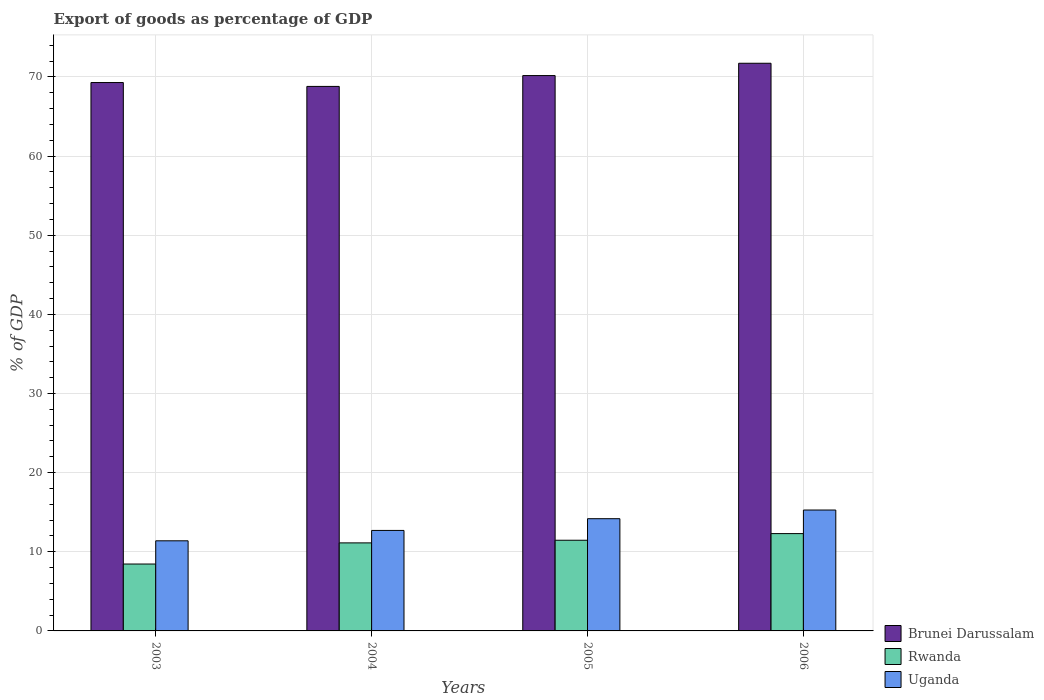How many different coloured bars are there?
Your answer should be compact. 3. How many groups of bars are there?
Offer a very short reply. 4. Are the number of bars per tick equal to the number of legend labels?
Make the answer very short. Yes. Are the number of bars on each tick of the X-axis equal?
Give a very brief answer. Yes. What is the export of goods as percentage of GDP in Uganda in 2004?
Your answer should be very brief. 12.7. Across all years, what is the maximum export of goods as percentage of GDP in Uganda?
Your answer should be compact. 15.28. Across all years, what is the minimum export of goods as percentage of GDP in Rwanda?
Provide a short and direct response. 8.45. In which year was the export of goods as percentage of GDP in Rwanda maximum?
Offer a terse response. 2006. What is the total export of goods as percentage of GDP in Uganda in the graph?
Provide a succinct answer. 53.54. What is the difference between the export of goods as percentage of GDP in Brunei Darussalam in 2003 and that in 2006?
Keep it short and to the point. -2.44. What is the difference between the export of goods as percentage of GDP in Rwanda in 2005 and the export of goods as percentage of GDP in Brunei Darussalam in 2004?
Offer a terse response. -57.34. What is the average export of goods as percentage of GDP in Brunei Darussalam per year?
Your response must be concise. 70. In the year 2004, what is the difference between the export of goods as percentage of GDP in Rwanda and export of goods as percentage of GDP in Brunei Darussalam?
Your answer should be very brief. -57.68. What is the ratio of the export of goods as percentage of GDP in Rwanda in 2005 to that in 2006?
Make the answer very short. 0.93. What is the difference between the highest and the second highest export of goods as percentage of GDP in Brunei Darussalam?
Give a very brief answer. 1.56. What is the difference between the highest and the lowest export of goods as percentage of GDP in Brunei Darussalam?
Your answer should be very brief. 2.93. Is the sum of the export of goods as percentage of GDP in Uganda in 2004 and 2005 greater than the maximum export of goods as percentage of GDP in Brunei Darussalam across all years?
Offer a terse response. No. What does the 2nd bar from the left in 2004 represents?
Your answer should be very brief. Rwanda. What does the 2nd bar from the right in 2005 represents?
Your answer should be very brief. Rwanda. Is it the case that in every year, the sum of the export of goods as percentage of GDP in Brunei Darussalam and export of goods as percentage of GDP in Rwanda is greater than the export of goods as percentage of GDP in Uganda?
Provide a short and direct response. Yes. Are all the bars in the graph horizontal?
Ensure brevity in your answer.  No. What is the difference between two consecutive major ticks on the Y-axis?
Offer a very short reply. 10. Are the values on the major ticks of Y-axis written in scientific E-notation?
Your response must be concise. No. Does the graph contain any zero values?
Your response must be concise. No. How many legend labels are there?
Your answer should be very brief. 3. How are the legend labels stacked?
Your response must be concise. Vertical. What is the title of the graph?
Your response must be concise. Export of goods as percentage of GDP. What is the label or title of the Y-axis?
Make the answer very short. % of GDP. What is the % of GDP in Brunei Darussalam in 2003?
Offer a very short reply. 69.29. What is the % of GDP of Rwanda in 2003?
Keep it short and to the point. 8.45. What is the % of GDP of Uganda in 2003?
Offer a very short reply. 11.39. What is the % of GDP of Brunei Darussalam in 2004?
Provide a short and direct response. 68.8. What is the % of GDP in Rwanda in 2004?
Ensure brevity in your answer.  11.12. What is the % of GDP in Uganda in 2004?
Offer a terse response. 12.7. What is the % of GDP of Brunei Darussalam in 2005?
Your answer should be very brief. 70.17. What is the % of GDP of Rwanda in 2005?
Provide a succinct answer. 11.46. What is the % of GDP of Uganda in 2005?
Your response must be concise. 14.18. What is the % of GDP in Brunei Darussalam in 2006?
Offer a very short reply. 71.72. What is the % of GDP in Rwanda in 2006?
Offer a terse response. 12.3. What is the % of GDP of Uganda in 2006?
Provide a short and direct response. 15.28. Across all years, what is the maximum % of GDP of Brunei Darussalam?
Keep it short and to the point. 71.72. Across all years, what is the maximum % of GDP in Rwanda?
Your answer should be compact. 12.3. Across all years, what is the maximum % of GDP of Uganda?
Make the answer very short. 15.28. Across all years, what is the minimum % of GDP in Brunei Darussalam?
Your answer should be compact. 68.8. Across all years, what is the minimum % of GDP in Rwanda?
Give a very brief answer. 8.45. Across all years, what is the minimum % of GDP in Uganda?
Your response must be concise. 11.39. What is the total % of GDP of Brunei Darussalam in the graph?
Your answer should be compact. 279.98. What is the total % of GDP in Rwanda in the graph?
Ensure brevity in your answer.  43.33. What is the total % of GDP of Uganda in the graph?
Offer a very short reply. 53.54. What is the difference between the % of GDP in Brunei Darussalam in 2003 and that in 2004?
Your response must be concise. 0.49. What is the difference between the % of GDP in Rwanda in 2003 and that in 2004?
Offer a terse response. -2.67. What is the difference between the % of GDP of Uganda in 2003 and that in 2004?
Ensure brevity in your answer.  -1.31. What is the difference between the % of GDP of Brunei Darussalam in 2003 and that in 2005?
Ensure brevity in your answer.  -0.88. What is the difference between the % of GDP in Rwanda in 2003 and that in 2005?
Your answer should be very brief. -3. What is the difference between the % of GDP of Uganda in 2003 and that in 2005?
Ensure brevity in your answer.  -2.79. What is the difference between the % of GDP in Brunei Darussalam in 2003 and that in 2006?
Provide a succinct answer. -2.44. What is the difference between the % of GDP of Rwanda in 2003 and that in 2006?
Your response must be concise. -3.84. What is the difference between the % of GDP in Uganda in 2003 and that in 2006?
Make the answer very short. -3.89. What is the difference between the % of GDP in Brunei Darussalam in 2004 and that in 2005?
Offer a very short reply. -1.37. What is the difference between the % of GDP of Rwanda in 2004 and that in 2005?
Your answer should be very brief. -0.33. What is the difference between the % of GDP in Uganda in 2004 and that in 2005?
Ensure brevity in your answer.  -1.48. What is the difference between the % of GDP of Brunei Darussalam in 2004 and that in 2006?
Provide a short and direct response. -2.93. What is the difference between the % of GDP in Rwanda in 2004 and that in 2006?
Your response must be concise. -1.17. What is the difference between the % of GDP in Uganda in 2004 and that in 2006?
Offer a very short reply. -2.58. What is the difference between the % of GDP in Brunei Darussalam in 2005 and that in 2006?
Give a very brief answer. -1.56. What is the difference between the % of GDP in Rwanda in 2005 and that in 2006?
Ensure brevity in your answer.  -0.84. What is the difference between the % of GDP in Uganda in 2005 and that in 2006?
Ensure brevity in your answer.  -1.1. What is the difference between the % of GDP in Brunei Darussalam in 2003 and the % of GDP in Rwanda in 2004?
Give a very brief answer. 58.17. What is the difference between the % of GDP in Brunei Darussalam in 2003 and the % of GDP in Uganda in 2004?
Keep it short and to the point. 56.59. What is the difference between the % of GDP in Rwanda in 2003 and the % of GDP in Uganda in 2004?
Give a very brief answer. -4.24. What is the difference between the % of GDP in Brunei Darussalam in 2003 and the % of GDP in Rwanda in 2005?
Provide a succinct answer. 57.83. What is the difference between the % of GDP of Brunei Darussalam in 2003 and the % of GDP of Uganda in 2005?
Keep it short and to the point. 55.11. What is the difference between the % of GDP in Rwanda in 2003 and the % of GDP in Uganda in 2005?
Your answer should be compact. -5.73. What is the difference between the % of GDP of Brunei Darussalam in 2003 and the % of GDP of Rwanda in 2006?
Keep it short and to the point. 56.99. What is the difference between the % of GDP in Brunei Darussalam in 2003 and the % of GDP in Uganda in 2006?
Make the answer very short. 54.01. What is the difference between the % of GDP of Rwanda in 2003 and the % of GDP of Uganda in 2006?
Your answer should be compact. -6.82. What is the difference between the % of GDP of Brunei Darussalam in 2004 and the % of GDP of Rwanda in 2005?
Provide a short and direct response. 57.34. What is the difference between the % of GDP of Brunei Darussalam in 2004 and the % of GDP of Uganda in 2005?
Make the answer very short. 54.62. What is the difference between the % of GDP of Rwanda in 2004 and the % of GDP of Uganda in 2005?
Your response must be concise. -3.06. What is the difference between the % of GDP of Brunei Darussalam in 2004 and the % of GDP of Rwanda in 2006?
Ensure brevity in your answer.  56.5. What is the difference between the % of GDP of Brunei Darussalam in 2004 and the % of GDP of Uganda in 2006?
Ensure brevity in your answer.  53.52. What is the difference between the % of GDP in Rwanda in 2004 and the % of GDP in Uganda in 2006?
Make the answer very short. -4.15. What is the difference between the % of GDP of Brunei Darussalam in 2005 and the % of GDP of Rwanda in 2006?
Provide a short and direct response. 57.87. What is the difference between the % of GDP in Brunei Darussalam in 2005 and the % of GDP in Uganda in 2006?
Your answer should be compact. 54.89. What is the difference between the % of GDP in Rwanda in 2005 and the % of GDP in Uganda in 2006?
Your answer should be compact. -3.82. What is the average % of GDP in Brunei Darussalam per year?
Your answer should be compact. 70. What is the average % of GDP of Rwanda per year?
Keep it short and to the point. 10.83. What is the average % of GDP in Uganda per year?
Ensure brevity in your answer.  13.38. In the year 2003, what is the difference between the % of GDP in Brunei Darussalam and % of GDP in Rwanda?
Your response must be concise. 60.84. In the year 2003, what is the difference between the % of GDP of Brunei Darussalam and % of GDP of Uganda?
Your answer should be compact. 57.9. In the year 2003, what is the difference between the % of GDP of Rwanda and % of GDP of Uganda?
Offer a very short reply. -2.93. In the year 2004, what is the difference between the % of GDP in Brunei Darussalam and % of GDP in Rwanda?
Keep it short and to the point. 57.67. In the year 2004, what is the difference between the % of GDP of Brunei Darussalam and % of GDP of Uganda?
Ensure brevity in your answer.  56.1. In the year 2004, what is the difference between the % of GDP of Rwanda and % of GDP of Uganda?
Keep it short and to the point. -1.57. In the year 2005, what is the difference between the % of GDP of Brunei Darussalam and % of GDP of Rwanda?
Provide a short and direct response. 58.71. In the year 2005, what is the difference between the % of GDP of Brunei Darussalam and % of GDP of Uganda?
Provide a short and direct response. 55.99. In the year 2005, what is the difference between the % of GDP of Rwanda and % of GDP of Uganda?
Your answer should be very brief. -2.72. In the year 2006, what is the difference between the % of GDP in Brunei Darussalam and % of GDP in Rwanda?
Keep it short and to the point. 59.43. In the year 2006, what is the difference between the % of GDP in Brunei Darussalam and % of GDP in Uganda?
Provide a succinct answer. 56.45. In the year 2006, what is the difference between the % of GDP of Rwanda and % of GDP of Uganda?
Keep it short and to the point. -2.98. What is the ratio of the % of GDP in Brunei Darussalam in 2003 to that in 2004?
Your answer should be very brief. 1.01. What is the ratio of the % of GDP in Rwanda in 2003 to that in 2004?
Your answer should be compact. 0.76. What is the ratio of the % of GDP in Uganda in 2003 to that in 2004?
Provide a short and direct response. 0.9. What is the ratio of the % of GDP in Brunei Darussalam in 2003 to that in 2005?
Your response must be concise. 0.99. What is the ratio of the % of GDP of Rwanda in 2003 to that in 2005?
Offer a terse response. 0.74. What is the ratio of the % of GDP in Uganda in 2003 to that in 2005?
Your answer should be compact. 0.8. What is the ratio of the % of GDP of Rwanda in 2003 to that in 2006?
Provide a short and direct response. 0.69. What is the ratio of the % of GDP of Uganda in 2003 to that in 2006?
Keep it short and to the point. 0.75. What is the ratio of the % of GDP in Brunei Darussalam in 2004 to that in 2005?
Provide a succinct answer. 0.98. What is the ratio of the % of GDP in Rwanda in 2004 to that in 2005?
Offer a very short reply. 0.97. What is the ratio of the % of GDP in Uganda in 2004 to that in 2005?
Provide a succinct answer. 0.9. What is the ratio of the % of GDP of Brunei Darussalam in 2004 to that in 2006?
Ensure brevity in your answer.  0.96. What is the ratio of the % of GDP of Rwanda in 2004 to that in 2006?
Provide a short and direct response. 0.9. What is the ratio of the % of GDP of Uganda in 2004 to that in 2006?
Provide a succinct answer. 0.83. What is the ratio of the % of GDP in Brunei Darussalam in 2005 to that in 2006?
Your answer should be very brief. 0.98. What is the ratio of the % of GDP of Rwanda in 2005 to that in 2006?
Ensure brevity in your answer.  0.93. What is the ratio of the % of GDP of Uganda in 2005 to that in 2006?
Your answer should be very brief. 0.93. What is the difference between the highest and the second highest % of GDP of Brunei Darussalam?
Your response must be concise. 1.56. What is the difference between the highest and the second highest % of GDP in Rwanda?
Your answer should be compact. 0.84. What is the difference between the highest and the second highest % of GDP of Uganda?
Offer a terse response. 1.1. What is the difference between the highest and the lowest % of GDP of Brunei Darussalam?
Ensure brevity in your answer.  2.93. What is the difference between the highest and the lowest % of GDP in Rwanda?
Your response must be concise. 3.84. What is the difference between the highest and the lowest % of GDP in Uganda?
Provide a short and direct response. 3.89. 